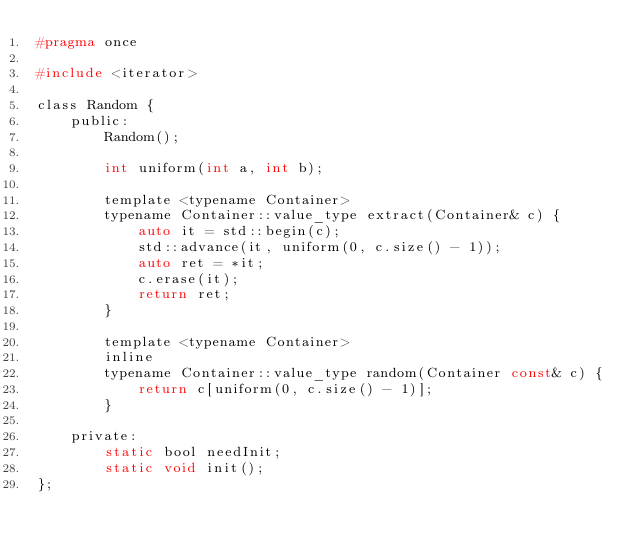<code> <loc_0><loc_0><loc_500><loc_500><_C_>#pragma once

#include <iterator>

class Random {
    public:
        Random();

        int uniform(int a, int b);

        template <typename Container>
        typename Container::value_type extract(Container& c) {
            auto it = std::begin(c);
            std::advance(it, uniform(0, c.size() - 1));
            auto ret = *it;
            c.erase(it);
            return ret;
        }
        
        template <typename Container>
        inline
        typename Container::value_type random(Container const& c) {
            return c[uniform(0, c.size() - 1)];
        }
        
    private:
        static bool needInit;
        static void init();
};
</code> 